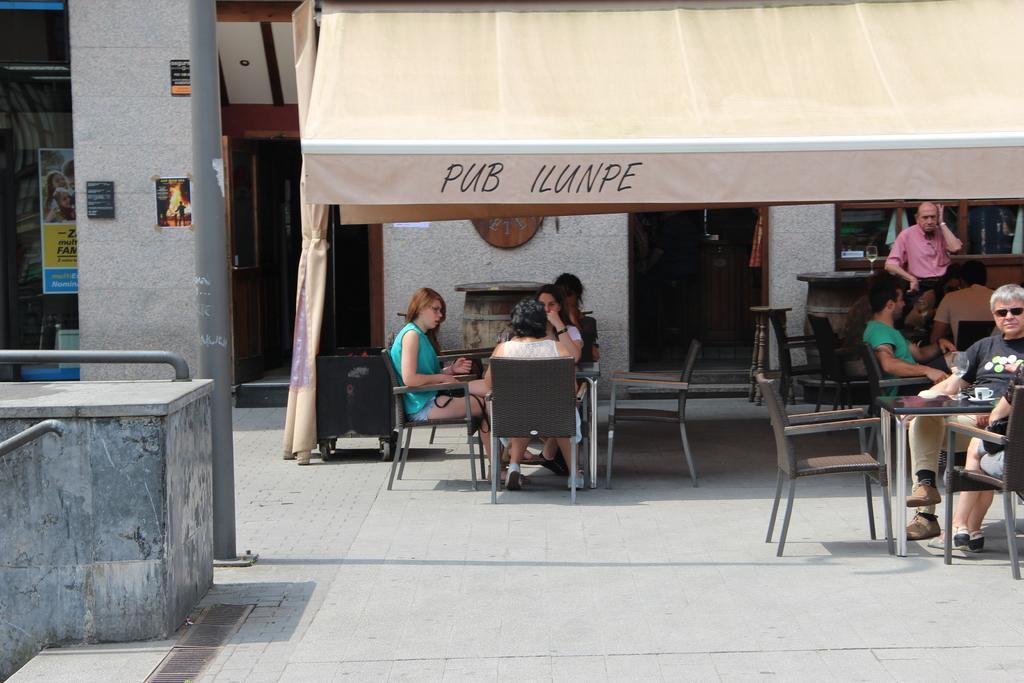Can you describe this image briefly? Here we can see a three women sitting on a chair on this tent and having a conversation. There is a man sitting on a chair on the right side. There is a person on the top right. 